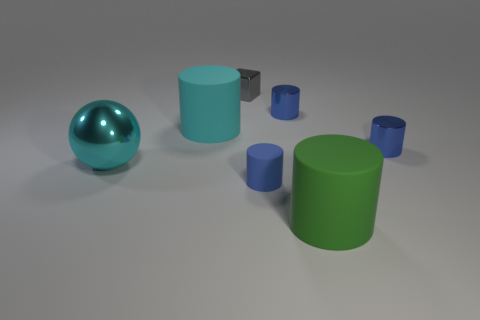Subtract all gray cubes. How many blue cylinders are left? 3 Subtract 1 cylinders. How many cylinders are left? 4 Subtract all cyan cylinders. How many cylinders are left? 4 Subtract all cyan rubber cylinders. How many cylinders are left? 4 Subtract all gray cylinders. Subtract all green spheres. How many cylinders are left? 5 Add 3 large things. How many objects exist? 10 Subtract all cylinders. How many objects are left? 2 Add 2 cyan objects. How many cyan objects are left? 4 Add 5 metallic blocks. How many metallic blocks exist? 6 Subtract 0 cyan blocks. How many objects are left? 7 